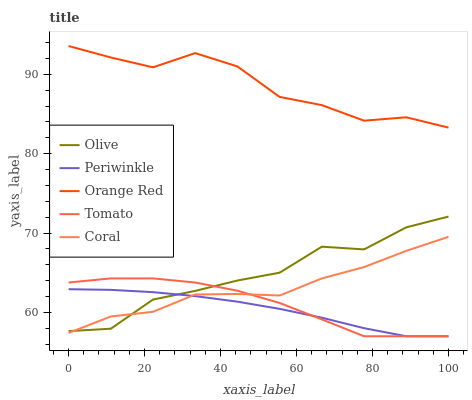Does Tomato have the minimum area under the curve?
Answer yes or no. No. Does Tomato have the maximum area under the curve?
Answer yes or no. No. Is Tomato the smoothest?
Answer yes or no. No. Is Tomato the roughest?
Answer yes or no. No. Does Coral have the lowest value?
Answer yes or no. No. Does Tomato have the highest value?
Answer yes or no. No. Is Tomato less than Orange Red?
Answer yes or no. Yes. Is Orange Red greater than Coral?
Answer yes or no. Yes. Does Tomato intersect Orange Red?
Answer yes or no. No. 